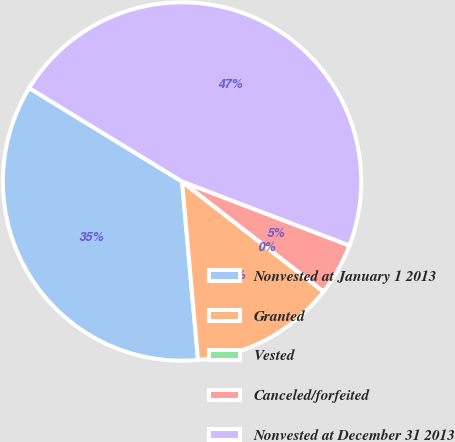Convert chart. <chart><loc_0><loc_0><loc_500><loc_500><pie_chart><fcel>Nonvested at January 1 2013<fcel>Granted<fcel>Vested<fcel>Canceled/forfeited<fcel>Nonvested at December 31 2013<nl><fcel>35.15%<fcel>13.06%<fcel>0.0%<fcel>4.71%<fcel>47.08%<nl></chart> 